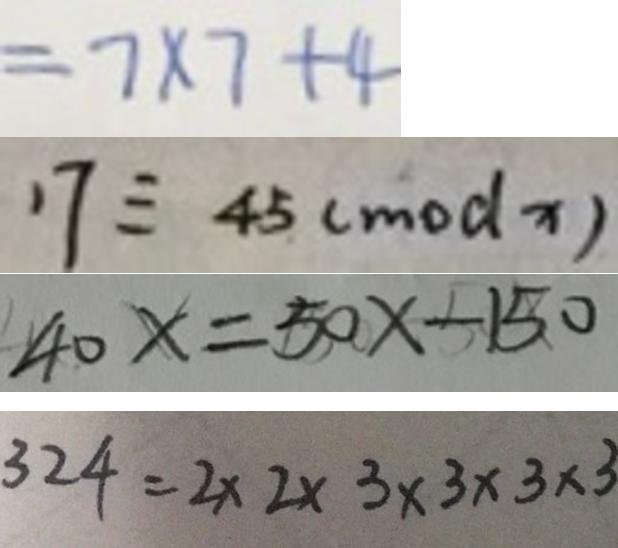<formula> <loc_0><loc_0><loc_500><loc_500>= 7 \times 7 + 4 
 1 7 \equiv 4 5 ( m o d x ) 
 4 0 x = 5 0 x - 1 5 0 
 3 2 4 = 2 \times 2 \times 3 \times 3 \times 3 \times 3</formula> 